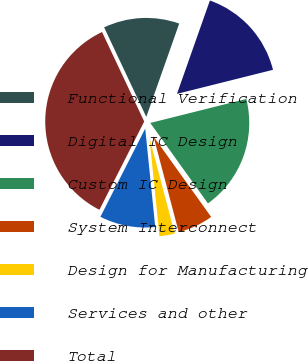<chart> <loc_0><loc_0><loc_500><loc_500><pie_chart><fcel>Functional Verification<fcel>Digital IC Design<fcel>Custom IC Design<fcel>System Interconnect<fcel>Design for Manufacturing<fcel>Services and other<fcel>Total<nl><fcel>12.4%<fcel>15.7%<fcel>19.01%<fcel>5.79%<fcel>2.49%<fcel>9.09%<fcel>35.52%<nl></chart> 